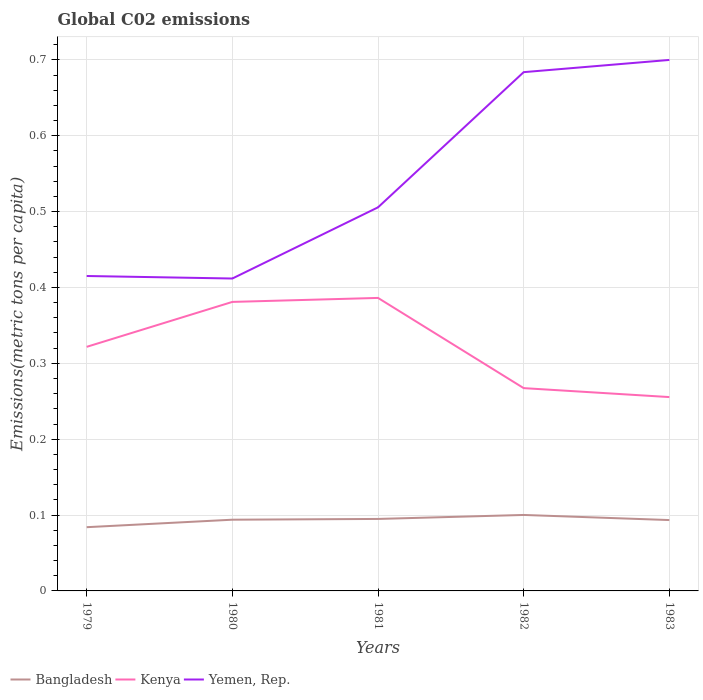How many different coloured lines are there?
Ensure brevity in your answer.  3. Does the line corresponding to Bangladesh intersect with the line corresponding to Kenya?
Your answer should be very brief. No. Across all years, what is the maximum amount of CO2 emitted in in Bangladesh?
Your response must be concise. 0.08. In which year was the amount of CO2 emitted in in Bangladesh maximum?
Offer a terse response. 1979. What is the total amount of CO2 emitted in in Bangladesh in the graph?
Your response must be concise. -0.02. What is the difference between the highest and the second highest amount of CO2 emitted in in Yemen, Rep.?
Your answer should be compact. 0.29. What is the difference between the highest and the lowest amount of CO2 emitted in in Yemen, Rep.?
Offer a terse response. 2. How many lines are there?
Your answer should be compact. 3. Are the values on the major ticks of Y-axis written in scientific E-notation?
Keep it short and to the point. No. Does the graph contain any zero values?
Your answer should be very brief. No. Where does the legend appear in the graph?
Make the answer very short. Bottom left. How many legend labels are there?
Ensure brevity in your answer.  3. How are the legend labels stacked?
Your answer should be compact. Horizontal. What is the title of the graph?
Your answer should be very brief. Global C02 emissions. What is the label or title of the Y-axis?
Offer a very short reply. Emissions(metric tons per capita). What is the Emissions(metric tons per capita) in Bangladesh in 1979?
Provide a succinct answer. 0.08. What is the Emissions(metric tons per capita) in Kenya in 1979?
Keep it short and to the point. 0.32. What is the Emissions(metric tons per capita) of Yemen, Rep. in 1979?
Make the answer very short. 0.42. What is the Emissions(metric tons per capita) of Bangladesh in 1980?
Your answer should be compact. 0.09. What is the Emissions(metric tons per capita) in Kenya in 1980?
Offer a terse response. 0.38. What is the Emissions(metric tons per capita) in Yemen, Rep. in 1980?
Provide a short and direct response. 0.41. What is the Emissions(metric tons per capita) in Bangladesh in 1981?
Offer a terse response. 0.09. What is the Emissions(metric tons per capita) in Kenya in 1981?
Offer a very short reply. 0.39. What is the Emissions(metric tons per capita) of Yemen, Rep. in 1981?
Offer a very short reply. 0.51. What is the Emissions(metric tons per capita) of Bangladesh in 1982?
Offer a terse response. 0.1. What is the Emissions(metric tons per capita) in Kenya in 1982?
Your answer should be compact. 0.27. What is the Emissions(metric tons per capita) of Yemen, Rep. in 1982?
Offer a very short reply. 0.68. What is the Emissions(metric tons per capita) in Bangladesh in 1983?
Make the answer very short. 0.09. What is the Emissions(metric tons per capita) of Kenya in 1983?
Your answer should be very brief. 0.26. What is the Emissions(metric tons per capita) of Yemen, Rep. in 1983?
Provide a short and direct response. 0.7. Across all years, what is the maximum Emissions(metric tons per capita) of Bangladesh?
Keep it short and to the point. 0.1. Across all years, what is the maximum Emissions(metric tons per capita) of Kenya?
Your answer should be compact. 0.39. Across all years, what is the maximum Emissions(metric tons per capita) of Yemen, Rep.?
Provide a succinct answer. 0.7. Across all years, what is the minimum Emissions(metric tons per capita) of Bangladesh?
Offer a very short reply. 0.08. Across all years, what is the minimum Emissions(metric tons per capita) of Kenya?
Your answer should be very brief. 0.26. Across all years, what is the minimum Emissions(metric tons per capita) in Yemen, Rep.?
Make the answer very short. 0.41. What is the total Emissions(metric tons per capita) in Bangladesh in the graph?
Provide a short and direct response. 0.47. What is the total Emissions(metric tons per capita) of Kenya in the graph?
Your response must be concise. 1.61. What is the total Emissions(metric tons per capita) in Yemen, Rep. in the graph?
Offer a very short reply. 2.72. What is the difference between the Emissions(metric tons per capita) of Bangladesh in 1979 and that in 1980?
Your response must be concise. -0.01. What is the difference between the Emissions(metric tons per capita) in Kenya in 1979 and that in 1980?
Give a very brief answer. -0.06. What is the difference between the Emissions(metric tons per capita) of Yemen, Rep. in 1979 and that in 1980?
Offer a terse response. 0. What is the difference between the Emissions(metric tons per capita) in Bangladesh in 1979 and that in 1981?
Give a very brief answer. -0.01. What is the difference between the Emissions(metric tons per capita) in Kenya in 1979 and that in 1981?
Your answer should be very brief. -0.06. What is the difference between the Emissions(metric tons per capita) of Yemen, Rep. in 1979 and that in 1981?
Give a very brief answer. -0.09. What is the difference between the Emissions(metric tons per capita) of Bangladesh in 1979 and that in 1982?
Keep it short and to the point. -0.02. What is the difference between the Emissions(metric tons per capita) of Kenya in 1979 and that in 1982?
Your answer should be compact. 0.05. What is the difference between the Emissions(metric tons per capita) in Yemen, Rep. in 1979 and that in 1982?
Your response must be concise. -0.27. What is the difference between the Emissions(metric tons per capita) in Bangladesh in 1979 and that in 1983?
Keep it short and to the point. -0.01. What is the difference between the Emissions(metric tons per capita) of Kenya in 1979 and that in 1983?
Ensure brevity in your answer.  0.07. What is the difference between the Emissions(metric tons per capita) of Yemen, Rep. in 1979 and that in 1983?
Make the answer very short. -0.28. What is the difference between the Emissions(metric tons per capita) in Bangladesh in 1980 and that in 1981?
Your answer should be very brief. -0. What is the difference between the Emissions(metric tons per capita) in Kenya in 1980 and that in 1981?
Your response must be concise. -0.01. What is the difference between the Emissions(metric tons per capita) in Yemen, Rep. in 1980 and that in 1981?
Provide a short and direct response. -0.09. What is the difference between the Emissions(metric tons per capita) in Bangladesh in 1980 and that in 1982?
Your response must be concise. -0.01. What is the difference between the Emissions(metric tons per capita) in Kenya in 1980 and that in 1982?
Provide a succinct answer. 0.11. What is the difference between the Emissions(metric tons per capita) in Yemen, Rep. in 1980 and that in 1982?
Your answer should be very brief. -0.27. What is the difference between the Emissions(metric tons per capita) of Kenya in 1980 and that in 1983?
Give a very brief answer. 0.13. What is the difference between the Emissions(metric tons per capita) in Yemen, Rep. in 1980 and that in 1983?
Provide a short and direct response. -0.29. What is the difference between the Emissions(metric tons per capita) in Bangladesh in 1981 and that in 1982?
Your answer should be very brief. -0.01. What is the difference between the Emissions(metric tons per capita) in Kenya in 1981 and that in 1982?
Provide a succinct answer. 0.12. What is the difference between the Emissions(metric tons per capita) in Yemen, Rep. in 1981 and that in 1982?
Offer a very short reply. -0.18. What is the difference between the Emissions(metric tons per capita) of Bangladesh in 1981 and that in 1983?
Provide a short and direct response. 0. What is the difference between the Emissions(metric tons per capita) in Kenya in 1981 and that in 1983?
Offer a very short reply. 0.13. What is the difference between the Emissions(metric tons per capita) in Yemen, Rep. in 1981 and that in 1983?
Make the answer very short. -0.19. What is the difference between the Emissions(metric tons per capita) in Bangladesh in 1982 and that in 1983?
Your response must be concise. 0.01. What is the difference between the Emissions(metric tons per capita) of Kenya in 1982 and that in 1983?
Offer a terse response. 0.01. What is the difference between the Emissions(metric tons per capita) in Yemen, Rep. in 1982 and that in 1983?
Offer a very short reply. -0.02. What is the difference between the Emissions(metric tons per capita) of Bangladesh in 1979 and the Emissions(metric tons per capita) of Kenya in 1980?
Provide a succinct answer. -0.3. What is the difference between the Emissions(metric tons per capita) in Bangladesh in 1979 and the Emissions(metric tons per capita) in Yemen, Rep. in 1980?
Offer a very short reply. -0.33. What is the difference between the Emissions(metric tons per capita) in Kenya in 1979 and the Emissions(metric tons per capita) in Yemen, Rep. in 1980?
Your answer should be very brief. -0.09. What is the difference between the Emissions(metric tons per capita) of Bangladesh in 1979 and the Emissions(metric tons per capita) of Kenya in 1981?
Your response must be concise. -0.3. What is the difference between the Emissions(metric tons per capita) of Bangladesh in 1979 and the Emissions(metric tons per capita) of Yemen, Rep. in 1981?
Offer a terse response. -0.42. What is the difference between the Emissions(metric tons per capita) in Kenya in 1979 and the Emissions(metric tons per capita) in Yemen, Rep. in 1981?
Provide a short and direct response. -0.18. What is the difference between the Emissions(metric tons per capita) in Bangladesh in 1979 and the Emissions(metric tons per capita) in Kenya in 1982?
Provide a succinct answer. -0.18. What is the difference between the Emissions(metric tons per capita) of Bangladesh in 1979 and the Emissions(metric tons per capita) of Yemen, Rep. in 1982?
Provide a short and direct response. -0.6. What is the difference between the Emissions(metric tons per capita) of Kenya in 1979 and the Emissions(metric tons per capita) of Yemen, Rep. in 1982?
Offer a very short reply. -0.36. What is the difference between the Emissions(metric tons per capita) in Bangladesh in 1979 and the Emissions(metric tons per capita) in Kenya in 1983?
Offer a terse response. -0.17. What is the difference between the Emissions(metric tons per capita) in Bangladesh in 1979 and the Emissions(metric tons per capita) in Yemen, Rep. in 1983?
Give a very brief answer. -0.62. What is the difference between the Emissions(metric tons per capita) of Kenya in 1979 and the Emissions(metric tons per capita) of Yemen, Rep. in 1983?
Your response must be concise. -0.38. What is the difference between the Emissions(metric tons per capita) of Bangladesh in 1980 and the Emissions(metric tons per capita) of Kenya in 1981?
Give a very brief answer. -0.29. What is the difference between the Emissions(metric tons per capita) in Bangladesh in 1980 and the Emissions(metric tons per capita) in Yemen, Rep. in 1981?
Your answer should be compact. -0.41. What is the difference between the Emissions(metric tons per capita) in Kenya in 1980 and the Emissions(metric tons per capita) in Yemen, Rep. in 1981?
Give a very brief answer. -0.12. What is the difference between the Emissions(metric tons per capita) in Bangladesh in 1980 and the Emissions(metric tons per capita) in Kenya in 1982?
Your answer should be compact. -0.17. What is the difference between the Emissions(metric tons per capita) in Bangladesh in 1980 and the Emissions(metric tons per capita) in Yemen, Rep. in 1982?
Your answer should be very brief. -0.59. What is the difference between the Emissions(metric tons per capita) in Kenya in 1980 and the Emissions(metric tons per capita) in Yemen, Rep. in 1982?
Make the answer very short. -0.3. What is the difference between the Emissions(metric tons per capita) of Bangladesh in 1980 and the Emissions(metric tons per capita) of Kenya in 1983?
Ensure brevity in your answer.  -0.16. What is the difference between the Emissions(metric tons per capita) of Bangladesh in 1980 and the Emissions(metric tons per capita) of Yemen, Rep. in 1983?
Provide a succinct answer. -0.61. What is the difference between the Emissions(metric tons per capita) of Kenya in 1980 and the Emissions(metric tons per capita) of Yemen, Rep. in 1983?
Give a very brief answer. -0.32. What is the difference between the Emissions(metric tons per capita) of Bangladesh in 1981 and the Emissions(metric tons per capita) of Kenya in 1982?
Your answer should be compact. -0.17. What is the difference between the Emissions(metric tons per capita) in Bangladesh in 1981 and the Emissions(metric tons per capita) in Yemen, Rep. in 1982?
Provide a short and direct response. -0.59. What is the difference between the Emissions(metric tons per capita) of Kenya in 1981 and the Emissions(metric tons per capita) of Yemen, Rep. in 1982?
Offer a terse response. -0.3. What is the difference between the Emissions(metric tons per capita) of Bangladesh in 1981 and the Emissions(metric tons per capita) of Kenya in 1983?
Your answer should be compact. -0.16. What is the difference between the Emissions(metric tons per capita) in Bangladesh in 1981 and the Emissions(metric tons per capita) in Yemen, Rep. in 1983?
Keep it short and to the point. -0.6. What is the difference between the Emissions(metric tons per capita) of Kenya in 1981 and the Emissions(metric tons per capita) of Yemen, Rep. in 1983?
Your answer should be compact. -0.31. What is the difference between the Emissions(metric tons per capita) of Bangladesh in 1982 and the Emissions(metric tons per capita) of Kenya in 1983?
Offer a very short reply. -0.16. What is the difference between the Emissions(metric tons per capita) of Bangladesh in 1982 and the Emissions(metric tons per capita) of Yemen, Rep. in 1983?
Your answer should be very brief. -0.6. What is the difference between the Emissions(metric tons per capita) in Kenya in 1982 and the Emissions(metric tons per capita) in Yemen, Rep. in 1983?
Ensure brevity in your answer.  -0.43. What is the average Emissions(metric tons per capita) in Bangladesh per year?
Offer a terse response. 0.09. What is the average Emissions(metric tons per capita) of Kenya per year?
Your answer should be compact. 0.32. What is the average Emissions(metric tons per capita) of Yemen, Rep. per year?
Make the answer very short. 0.54. In the year 1979, what is the difference between the Emissions(metric tons per capita) of Bangladesh and Emissions(metric tons per capita) of Kenya?
Make the answer very short. -0.24. In the year 1979, what is the difference between the Emissions(metric tons per capita) in Bangladesh and Emissions(metric tons per capita) in Yemen, Rep.?
Give a very brief answer. -0.33. In the year 1979, what is the difference between the Emissions(metric tons per capita) of Kenya and Emissions(metric tons per capita) of Yemen, Rep.?
Your response must be concise. -0.09. In the year 1980, what is the difference between the Emissions(metric tons per capita) in Bangladesh and Emissions(metric tons per capita) in Kenya?
Provide a short and direct response. -0.29. In the year 1980, what is the difference between the Emissions(metric tons per capita) of Bangladesh and Emissions(metric tons per capita) of Yemen, Rep.?
Offer a terse response. -0.32. In the year 1980, what is the difference between the Emissions(metric tons per capita) in Kenya and Emissions(metric tons per capita) in Yemen, Rep.?
Provide a succinct answer. -0.03. In the year 1981, what is the difference between the Emissions(metric tons per capita) of Bangladesh and Emissions(metric tons per capita) of Kenya?
Ensure brevity in your answer.  -0.29. In the year 1981, what is the difference between the Emissions(metric tons per capita) of Bangladesh and Emissions(metric tons per capita) of Yemen, Rep.?
Provide a short and direct response. -0.41. In the year 1981, what is the difference between the Emissions(metric tons per capita) of Kenya and Emissions(metric tons per capita) of Yemen, Rep.?
Your response must be concise. -0.12. In the year 1982, what is the difference between the Emissions(metric tons per capita) of Bangladesh and Emissions(metric tons per capita) of Kenya?
Make the answer very short. -0.17. In the year 1982, what is the difference between the Emissions(metric tons per capita) in Bangladesh and Emissions(metric tons per capita) in Yemen, Rep.?
Ensure brevity in your answer.  -0.58. In the year 1982, what is the difference between the Emissions(metric tons per capita) of Kenya and Emissions(metric tons per capita) of Yemen, Rep.?
Give a very brief answer. -0.42. In the year 1983, what is the difference between the Emissions(metric tons per capita) in Bangladesh and Emissions(metric tons per capita) in Kenya?
Your answer should be very brief. -0.16. In the year 1983, what is the difference between the Emissions(metric tons per capita) of Bangladesh and Emissions(metric tons per capita) of Yemen, Rep.?
Provide a short and direct response. -0.61. In the year 1983, what is the difference between the Emissions(metric tons per capita) of Kenya and Emissions(metric tons per capita) of Yemen, Rep.?
Your answer should be very brief. -0.44. What is the ratio of the Emissions(metric tons per capita) of Bangladesh in 1979 to that in 1980?
Your answer should be compact. 0.89. What is the ratio of the Emissions(metric tons per capita) in Kenya in 1979 to that in 1980?
Your answer should be compact. 0.84. What is the ratio of the Emissions(metric tons per capita) in Bangladesh in 1979 to that in 1981?
Provide a short and direct response. 0.89. What is the ratio of the Emissions(metric tons per capita) of Kenya in 1979 to that in 1981?
Make the answer very short. 0.83. What is the ratio of the Emissions(metric tons per capita) in Yemen, Rep. in 1979 to that in 1981?
Give a very brief answer. 0.82. What is the ratio of the Emissions(metric tons per capita) of Bangladesh in 1979 to that in 1982?
Your response must be concise. 0.84. What is the ratio of the Emissions(metric tons per capita) of Kenya in 1979 to that in 1982?
Give a very brief answer. 1.2. What is the ratio of the Emissions(metric tons per capita) of Yemen, Rep. in 1979 to that in 1982?
Your answer should be compact. 0.61. What is the ratio of the Emissions(metric tons per capita) of Bangladesh in 1979 to that in 1983?
Your answer should be compact. 0.9. What is the ratio of the Emissions(metric tons per capita) of Kenya in 1979 to that in 1983?
Keep it short and to the point. 1.26. What is the ratio of the Emissions(metric tons per capita) in Yemen, Rep. in 1979 to that in 1983?
Your answer should be compact. 0.59. What is the ratio of the Emissions(metric tons per capita) of Kenya in 1980 to that in 1981?
Offer a terse response. 0.99. What is the ratio of the Emissions(metric tons per capita) in Yemen, Rep. in 1980 to that in 1981?
Offer a very short reply. 0.81. What is the ratio of the Emissions(metric tons per capita) in Bangladesh in 1980 to that in 1982?
Your answer should be compact. 0.94. What is the ratio of the Emissions(metric tons per capita) of Kenya in 1980 to that in 1982?
Keep it short and to the point. 1.43. What is the ratio of the Emissions(metric tons per capita) of Yemen, Rep. in 1980 to that in 1982?
Provide a short and direct response. 0.6. What is the ratio of the Emissions(metric tons per capita) in Bangladesh in 1980 to that in 1983?
Provide a succinct answer. 1.01. What is the ratio of the Emissions(metric tons per capita) in Kenya in 1980 to that in 1983?
Ensure brevity in your answer.  1.49. What is the ratio of the Emissions(metric tons per capita) of Yemen, Rep. in 1980 to that in 1983?
Offer a terse response. 0.59. What is the ratio of the Emissions(metric tons per capita) of Bangladesh in 1981 to that in 1982?
Make the answer very short. 0.95. What is the ratio of the Emissions(metric tons per capita) in Kenya in 1981 to that in 1982?
Provide a short and direct response. 1.44. What is the ratio of the Emissions(metric tons per capita) in Yemen, Rep. in 1981 to that in 1982?
Your answer should be compact. 0.74. What is the ratio of the Emissions(metric tons per capita) of Bangladesh in 1981 to that in 1983?
Ensure brevity in your answer.  1.02. What is the ratio of the Emissions(metric tons per capita) in Kenya in 1981 to that in 1983?
Keep it short and to the point. 1.51. What is the ratio of the Emissions(metric tons per capita) of Yemen, Rep. in 1981 to that in 1983?
Your response must be concise. 0.72. What is the ratio of the Emissions(metric tons per capita) in Bangladesh in 1982 to that in 1983?
Your answer should be very brief. 1.07. What is the ratio of the Emissions(metric tons per capita) in Kenya in 1982 to that in 1983?
Make the answer very short. 1.05. What is the ratio of the Emissions(metric tons per capita) of Yemen, Rep. in 1982 to that in 1983?
Your response must be concise. 0.98. What is the difference between the highest and the second highest Emissions(metric tons per capita) of Bangladesh?
Ensure brevity in your answer.  0.01. What is the difference between the highest and the second highest Emissions(metric tons per capita) in Kenya?
Offer a very short reply. 0.01. What is the difference between the highest and the second highest Emissions(metric tons per capita) in Yemen, Rep.?
Your response must be concise. 0.02. What is the difference between the highest and the lowest Emissions(metric tons per capita) of Bangladesh?
Ensure brevity in your answer.  0.02. What is the difference between the highest and the lowest Emissions(metric tons per capita) of Kenya?
Your response must be concise. 0.13. What is the difference between the highest and the lowest Emissions(metric tons per capita) in Yemen, Rep.?
Provide a succinct answer. 0.29. 